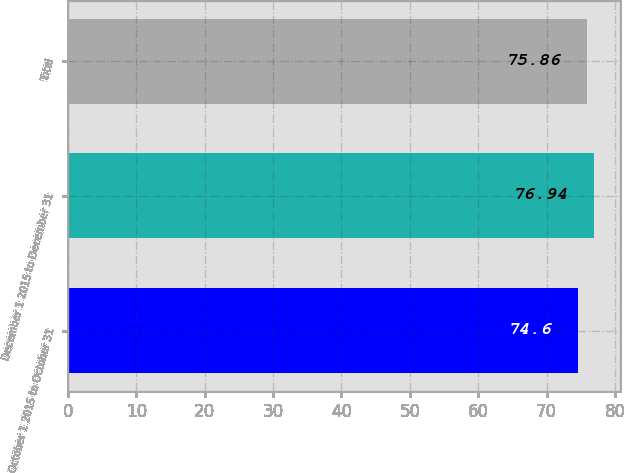<chart> <loc_0><loc_0><loc_500><loc_500><bar_chart><fcel>October 1 2015 to October 31<fcel>December 1 2015 to December 31<fcel>Total<nl><fcel>74.6<fcel>76.94<fcel>75.86<nl></chart> 